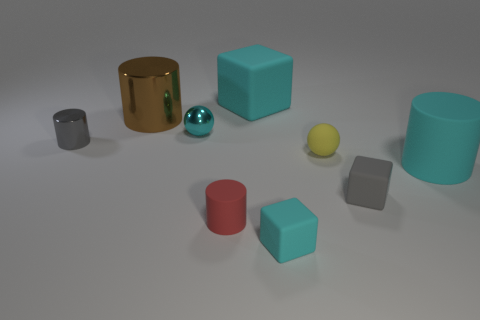What material is the ball that is the same size as the yellow rubber object?
Keep it short and to the point. Metal. How many other objects are there of the same material as the cyan cylinder?
Your response must be concise. 5. There is a matte thing behind the brown object; is its shape the same as the gray metal object left of the red cylinder?
Give a very brief answer. No. How many other things are the same color as the big shiny cylinder?
Make the answer very short. 0. Does the large object on the left side of the large cyan block have the same material as the small cylinder that is to the left of the cyan ball?
Keep it short and to the point. Yes. Are there the same number of gray shiny cylinders that are to the left of the tiny gray metallic thing and gray shiny cylinders that are on the right side of the red cylinder?
Offer a very short reply. Yes. There is a tiny cyan object to the left of the large matte block; what material is it?
Ensure brevity in your answer.  Metal. Is the number of tiny matte blocks less than the number of small red blocks?
Make the answer very short. No. There is a rubber thing that is both to the right of the red cylinder and in front of the gray rubber thing; what is its shape?
Your response must be concise. Cube. What number of blocks are there?
Provide a succinct answer. 3. 